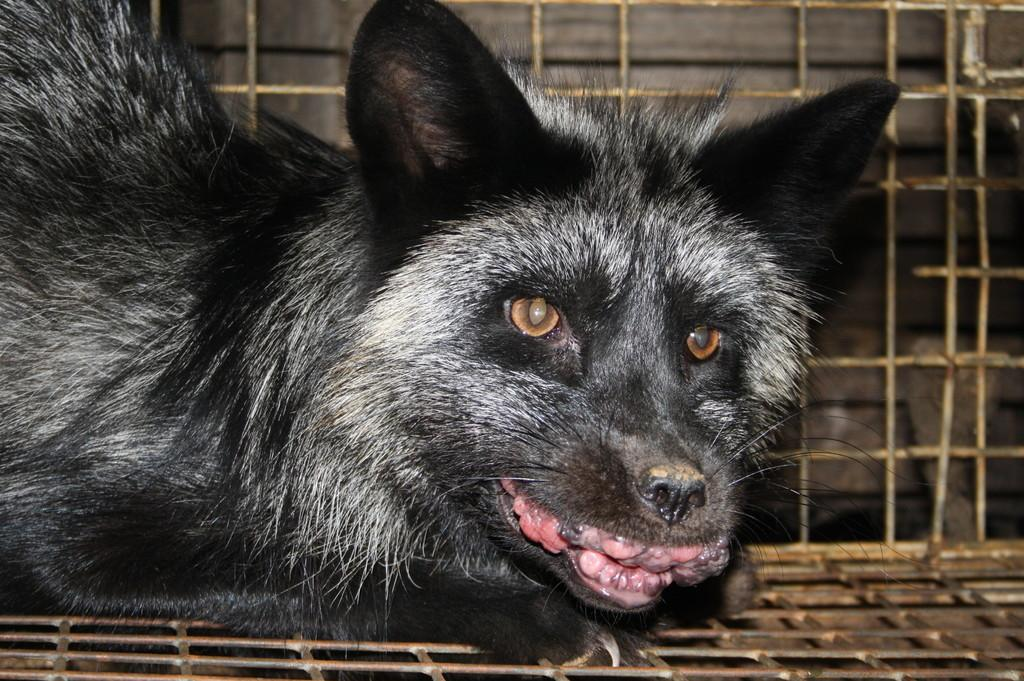What type of creature is present in the image? There is an animal in the image. What is the color of the animal? The animal is black in color. Where is the animal located in the image? The animal is in a cage. What material is the cage made of? The cage is made up of metal. What type of protest is happening outside the cage in the image? There is no protest present in the image; it only features an animal in a metal cage. How many balloons are tied to the animal in the image? There are no balloons present in the image; the animal is simply in a metal cage. 